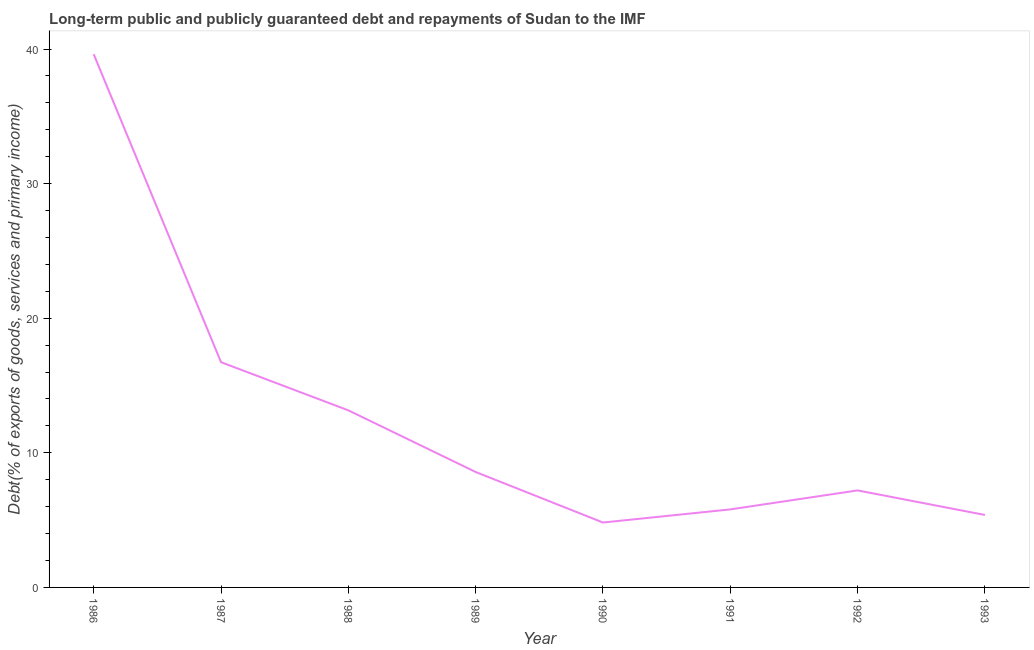What is the debt service in 1992?
Provide a short and direct response. 7.21. Across all years, what is the maximum debt service?
Give a very brief answer. 39.61. Across all years, what is the minimum debt service?
Your answer should be compact. 4.82. What is the sum of the debt service?
Offer a terse response. 101.29. What is the difference between the debt service in 1988 and 1993?
Your answer should be compact. 7.77. What is the average debt service per year?
Offer a terse response. 12.66. What is the median debt service?
Make the answer very short. 7.89. In how many years, is the debt service greater than 2 %?
Offer a terse response. 8. What is the ratio of the debt service in 1989 to that in 1992?
Give a very brief answer. 1.19. What is the difference between the highest and the second highest debt service?
Your answer should be compact. 22.88. Is the sum of the debt service in 1987 and 1991 greater than the maximum debt service across all years?
Your answer should be compact. No. What is the difference between the highest and the lowest debt service?
Your response must be concise. 34.79. In how many years, is the debt service greater than the average debt service taken over all years?
Provide a succinct answer. 3. How many lines are there?
Your answer should be very brief. 1. What is the difference between two consecutive major ticks on the Y-axis?
Offer a very short reply. 10. Are the values on the major ticks of Y-axis written in scientific E-notation?
Offer a very short reply. No. Does the graph contain any zero values?
Provide a succinct answer. No. What is the title of the graph?
Provide a short and direct response. Long-term public and publicly guaranteed debt and repayments of Sudan to the IMF. What is the label or title of the X-axis?
Ensure brevity in your answer.  Year. What is the label or title of the Y-axis?
Offer a very short reply. Debt(% of exports of goods, services and primary income). What is the Debt(% of exports of goods, services and primary income) of 1986?
Your answer should be compact. 39.61. What is the Debt(% of exports of goods, services and primary income) in 1987?
Give a very brief answer. 16.74. What is the Debt(% of exports of goods, services and primary income) of 1988?
Your response must be concise. 13.16. What is the Debt(% of exports of goods, services and primary income) of 1989?
Your response must be concise. 8.58. What is the Debt(% of exports of goods, services and primary income) in 1990?
Provide a short and direct response. 4.82. What is the Debt(% of exports of goods, services and primary income) of 1991?
Ensure brevity in your answer.  5.8. What is the Debt(% of exports of goods, services and primary income) in 1992?
Keep it short and to the point. 7.21. What is the Debt(% of exports of goods, services and primary income) in 1993?
Your answer should be very brief. 5.38. What is the difference between the Debt(% of exports of goods, services and primary income) in 1986 and 1987?
Keep it short and to the point. 22.88. What is the difference between the Debt(% of exports of goods, services and primary income) in 1986 and 1988?
Your answer should be very brief. 26.46. What is the difference between the Debt(% of exports of goods, services and primary income) in 1986 and 1989?
Your answer should be very brief. 31.04. What is the difference between the Debt(% of exports of goods, services and primary income) in 1986 and 1990?
Offer a terse response. 34.79. What is the difference between the Debt(% of exports of goods, services and primary income) in 1986 and 1991?
Offer a terse response. 33.82. What is the difference between the Debt(% of exports of goods, services and primary income) in 1986 and 1992?
Provide a short and direct response. 32.41. What is the difference between the Debt(% of exports of goods, services and primary income) in 1986 and 1993?
Give a very brief answer. 34.23. What is the difference between the Debt(% of exports of goods, services and primary income) in 1987 and 1988?
Provide a succinct answer. 3.58. What is the difference between the Debt(% of exports of goods, services and primary income) in 1987 and 1989?
Offer a very short reply. 8.16. What is the difference between the Debt(% of exports of goods, services and primary income) in 1987 and 1990?
Make the answer very short. 11.91. What is the difference between the Debt(% of exports of goods, services and primary income) in 1987 and 1991?
Provide a short and direct response. 10.94. What is the difference between the Debt(% of exports of goods, services and primary income) in 1987 and 1992?
Give a very brief answer. 9.53. What is the difference between the Debt(% of exports of goods, services and primary income) in 1987 and 1993?
Your answer should be compact. 11.35. What is the difference between the Debt(% of exports of goods, services and primary income) in 1988 and 1989?
Provide a short and direct response. 4.58. What is the difference between the Debt(% of exports of goods, services and primary income) in 1988 and 1990?
Give a very brief answer. 8.33. What is the difference between the Debt(% of exports of goods, services and primary income) in 1988 and 1991?
Make the answer very short. 7.36. What is the difference between the Debt(% of exports of goods, services and primary income) in 1988 and 1992?
Your answer should be compact. 5.95. What is the difference between the Debt(% of exports of goods, services and primary income) in 1988 and 1993?
Your answer should be very brief. 7.77. What is the difference between the Debt(% of exports of goods, services and primary income) in 1989 and 1990?
Make the answer very short. 3.75. What is the difference between the Debt(% of exports of goods, services and primary income) in 1989 and 1991?
Offer a terse response. 2.78. What is the difference between the Debt(% of exports of goods, services and primary income) in 1989 and 1992?
Provide a succinct answer. 1.37. What is the difference between the Debt(% of exports of goods, services and primary income) in 1989 and 1993?
Provide a succinct answer. 3.19. What is the difference between the Debt(% of exports of goods, services and primary income) in 1990 and 1991?
Your answer should be very brief. -0.98. What is the difference between the Debt(% of exports of goods, services and primary income) in 1990 and 1992?
Provide a succinct answer. -2.38. What is the difference between the Debt(% of exports of goods, services and primary income) in 1990 and 1993?
Ensure brevity in your answer.  -0.56. What is the difference between the Debt(% of exports of goods, services and primary income) in 1991 and 1992?
Make the answer very short. -1.41. What is the difference between the Debt(% of exports of goods, services and primary income) in 1991 and 1993?
Offer a very short reply. 0.41. What is the difference between the Debt(% of exports of goods, services and primary income) in 1992 and 1993?
Provide a succinct answer. 1.82. What is the ratio of the Debt(% of exports of goods, services and primary income) in 1986 to that in 1987?
Your answer should be compact. 2.37. What is the ratio of the Debt(% of exports of goods, services and primary income) in 1986 to that in 1988?
Ensure brevity in your answer.  3.01. What is the ratio of the Debt(% of exports of goods, services and primary income) in 1986 to that in 1989?
Provide a succinct answer. 4.62. What is the ratio of the Debt(% of exports of goods, services and primary income) in 1986 to that in 1990?
Provide a succinct answer. 8.21. What is the ratio of the Debt(% of exports of goods, services and primary income) in 1986 to that in 1991?
Offer a terse response. 6.83. What is the ratio of the Debt(% of exports of goods, services and primary income) in 1986 to that in 1992?
Ensure brevity in your answer.  5.5. What is the ratio of the Debt(% of exports of goods, services and primary income) in 1986 to that in 1993?
Your response must be concise. 7.36. What is the ratio of the Debt(% of exports of goods, services and primary income) in 1987 to that in 1988?
Your answer should be very brief. 1.27. What is the ratio of the Debt(% of exports of goods, services and primary income) in 1987 to that in 1989?
Ensure brevity in your answer.  1.95. What is the ratio of the Debt(% of exports of goods, services and primary income) in 1987 to that in 1990?
Your answer should be compact. 3.47. What is the ratio of the Debt(% of exports of goods, services and primary income) in 1987 to that in 1991?
Your answer should be very brief. 2.89. What is the ratio of the Debt(% of exports of goods, services and primary income) in 1987 to that in 1992?
Provide a short and direct response. 2.32. What is the ratio of the Debt(% of exports of goods, services and primary income) in 1987 to that in 1993?
Give a very brief answer. 3.11. What is the ratio of the Debt(% of exports of goods, services and primary income) in 1988 to that in 1989?
Your answer should be very brief. 1.53. What is the ratio of the Debt(% of exports of goods, services and primary income) in 1988 to that in 1990?
Your answer should be very brief. 2.73. What is the ratio of the Debt(% of exports of goods, services and primary income) in 1988 to that in 1991?
Offer a terse response. 2.27. What is the ratio of the Debt(% of exports of goods, services and primary income) in 1988 to that in 1992?
Ensure brevity in your answer.  1.83. What is the ratio of the Debt(% of exports of goods, services and primary income) in 1988 to that in 1993?
Your answer should be compact. 2.44. What is the ratio of the Debt(% of exports of goods, services and primary income) in 1989 to that in 1990?
Your answer should be very brief. 1.78. What is the ratio of the Debt(% of exports of goods, services and primary income) in 1989 to that in 1991?
Provide a succinct answer. 1.48. What is the ratio of the Debt(% of exports of goods, services and primary income) in 1989 to that in 1992?
Your answer should be compact. 1.19. What is the ratio of the Debt(% of exports of goods, services and primary income) in 1989 to that in 1993?
Offer a very short reply. 1.59. What is the ratio of the Debt(% of exports of goods, services and primary income) in 1990 to that in 1991?
Provide a succinct answer. 0.83. What is the ratio of the Debt(% of exports of goods, services and primary income) in 1990 to that in 1992?
Keep it short and to the point. 0.67. What is the ratio of the Debt(% of exports of goods, services and primary income) in 1990 to that in 1993?
Provide a short and direct response. 0.9. What is the ratio of the Debt(% of exports of goods, services and primary income) in 1991 to that in 1992?
Ensure brevity in your answer.  0.8. What is the ratio of the Debt(% of exports of goods, services and primary income) in 1991 to that in 1993?
Your answer should be very brief. 1.08. What is the ratio of the Debt(% of exports of goods, services and primary income) in 1992 to that in 1993?
Offer a terse response. 1.34. 